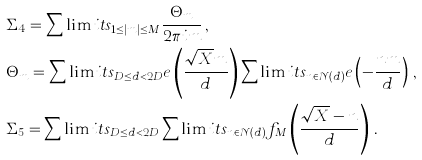Convert formula to latex. <formula><loc_0><loc_0><loc_500><loc_500>& \Sigma _ { 4 } = \sum \lim i t s _ { 1 \leq | m | \leq M } \frac { \Theta _ { m } } { 2 \pi i m } \, , \\ & \Theta _ { m } = \sum \lim i t s _ { D \leq d < 2 D } e \left ( \frac { \sqrt { X } m } { d } \right ) \sum \lim i t s _ { n \in \mathcal { N } ( d ) } e \left ( - \frac { n m } { d } \right ) \, , \\ & \Sigma _ { 5 } = \sum \lim i t s _ { D \leq d < 2 D } \sum \lim i t s _ { n \in \mathcal { N } ( d ) } f _ { M } \left ( \frac { \sqrt { X } - n } { d } \right ) \, .</formula> 